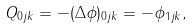Convert formula to latex. <formula><loc_0><loc_0><loc_500><loc_500>Q _ { 0 j k } = - ( \Delta { \phi } ) _ { 0 j k } = - \phi _ { 1 j k } ,</formula> 